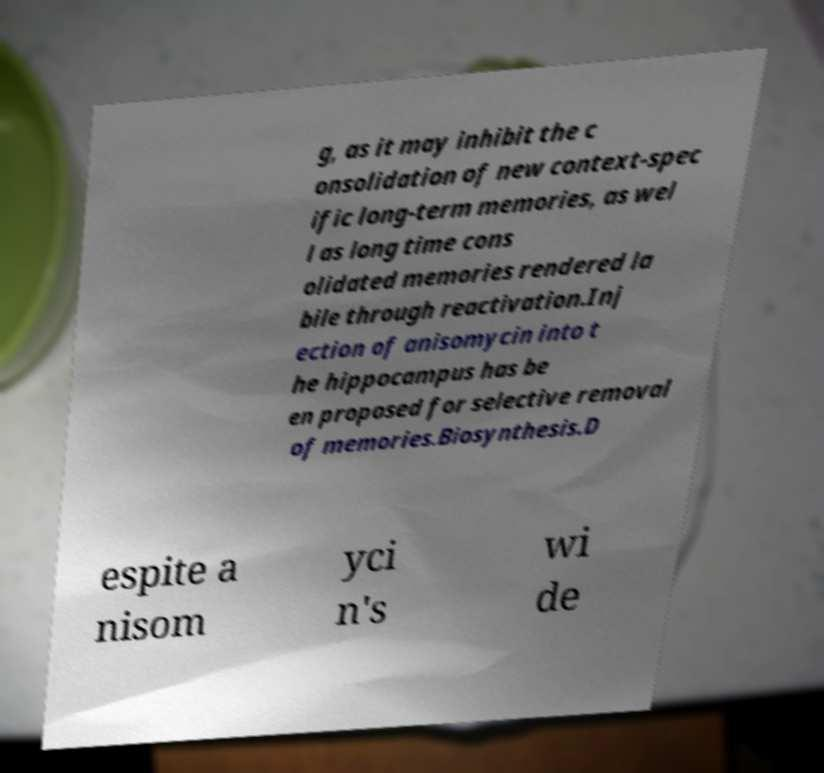Please identify and transcribe the text found in this image. g, as it may inhibit the c onsolidation of new context-spec ific long-term memories, as wel l as long time cons olidated memories rendered la bile through reactivation.Inj ection of anisomycin into t he hippocampus has be en proposed for selective removal of memories.Biosynthesis.D espite a nisom yci n's wi de 